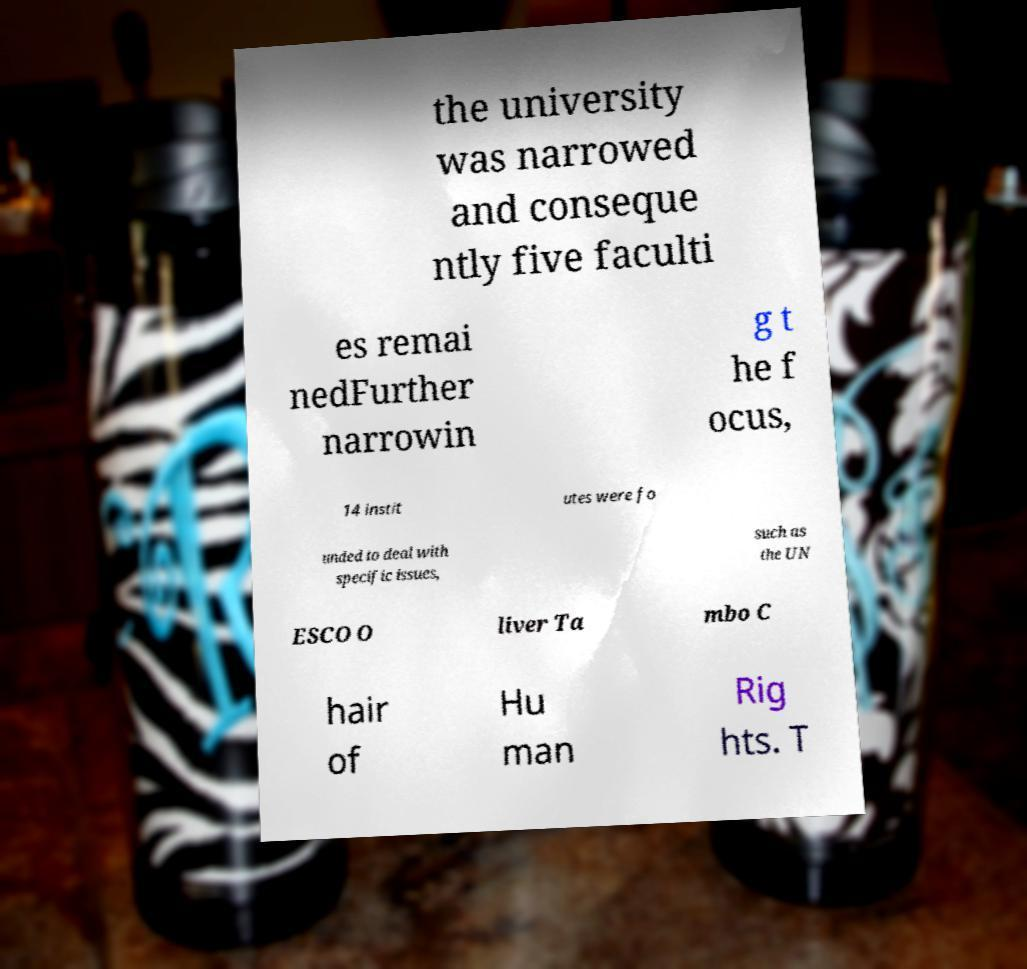I need the written content from this picture converted into text. Can you do that? the university was narrowed and conseque ntly five faculti es remai nedFurther narrowin g t he f ocus, 14 instit utes were fo unded to deal with specific issues, such as the UN ESCO O liver Ta mbo C hair of Hu man Rig hts. T 